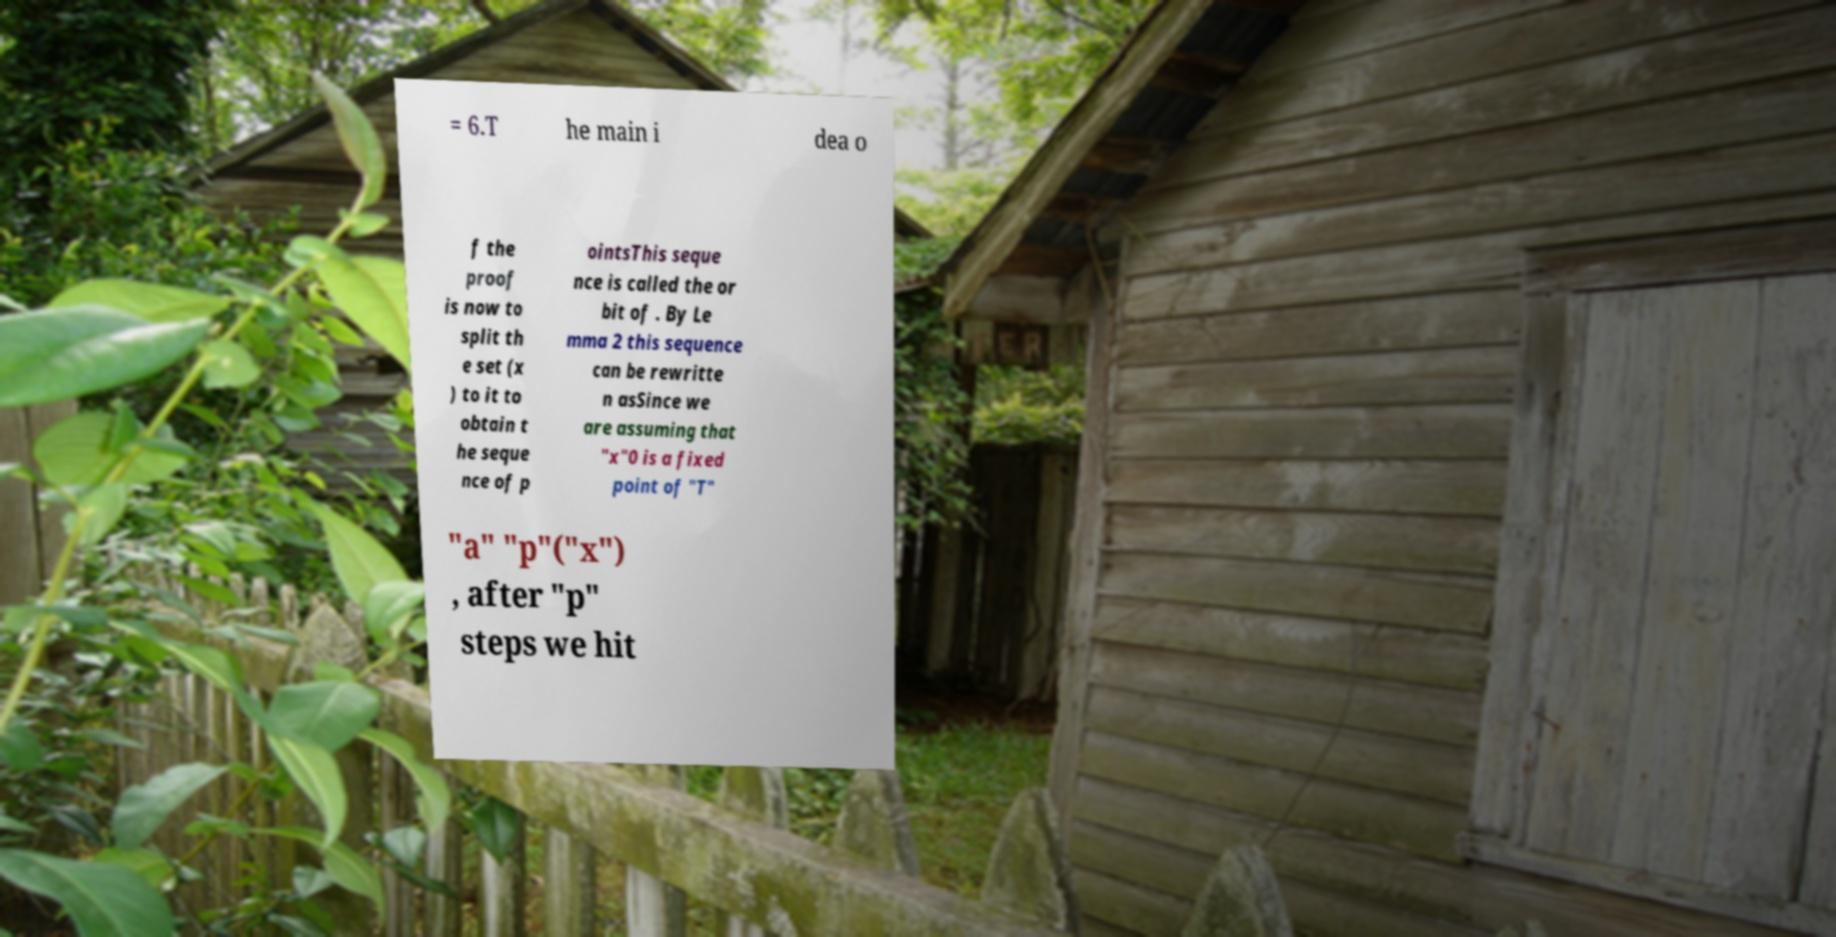What messages or text are displayed in this image? I need them in a readable, typed format. = 6.T he main i dea o f the proof is now to split th e set (x ) to it to obtain t he seque nce of p ointsThis seque nce is called the or bit of . By Le mma 2 this sequence can be rewritte n asSince we are assuming that "x"0 is a fixed point of "T" "a" "p"("x") , after "p" steps we hit 